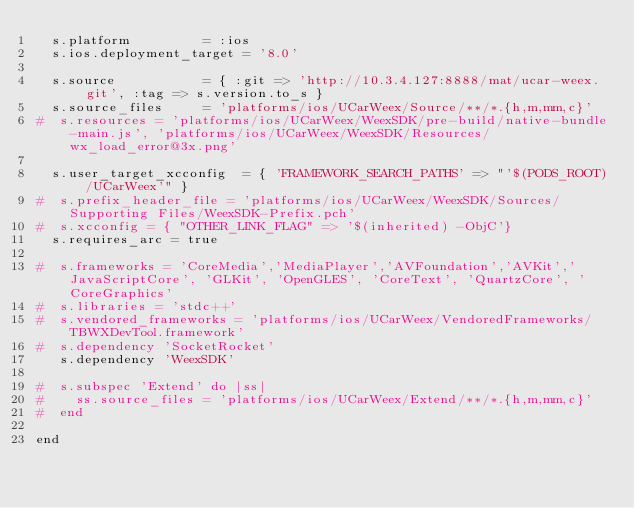<code> <loc_0><loc_0><loc_500><loc_500><_Ruby_>  s.platform         = :ios
  s.ios.deployment_target = '8.0'

  s.source           = { :git => 'http://10.3.4.127:8888/mat/ucar-weex.git', :tag => s.version.to_s }
  s.source_files     = 'platforms/ios/UCarWeex/Source/**/*.{h,m,mm,c}'
#  s.resources = 'platforms/ios/UCarWeex/WeexSDK/pre-build/native-bundle-main.js', 'platforms/ios/UCarWeex/WeexSDK/Resources/wx_load_error@3x.png'

  s.user_target_xcconfig  = { 'FRAMEWORK_SEARCH_PATHS' => "'$(PODS_ROOT)/UCarWeex'" }
#  s.prefix_header_file = 'platforms/ios/UCarWeex/WeexSDK/Sources/Supporting Files/WeexSDK-Prefix.pch'
#  s.xcconfig = { "OTHER_LINK_FLAG" => '$(inherited) -ObjC'}
  s.requires_arc = true

#  s.frameworks = 'CoreMedia','MediaPlayer','AVFoundation','AVKit','JavaScriptCore', 'GLKit', 'OpenGLES', 'CoreText', 'QuartzCore', 'CoreGraphics'
#  s.libraries = 'stdc++'
#  s.vendored_frameworks = 'platforms/ios/UCarWeex/VendoredFrameworks/TBWXDevTool.framework'
#  s.dependency 'SocketRocket'
   s.dependency 'WeexSDK'

#  s.subspec 'Extend' do |ss|
#    ss.source_files = 'platforms/ios/UCarWeex/Extend/**/*.{h,m,mm,c}'
#  end

end
</code> 